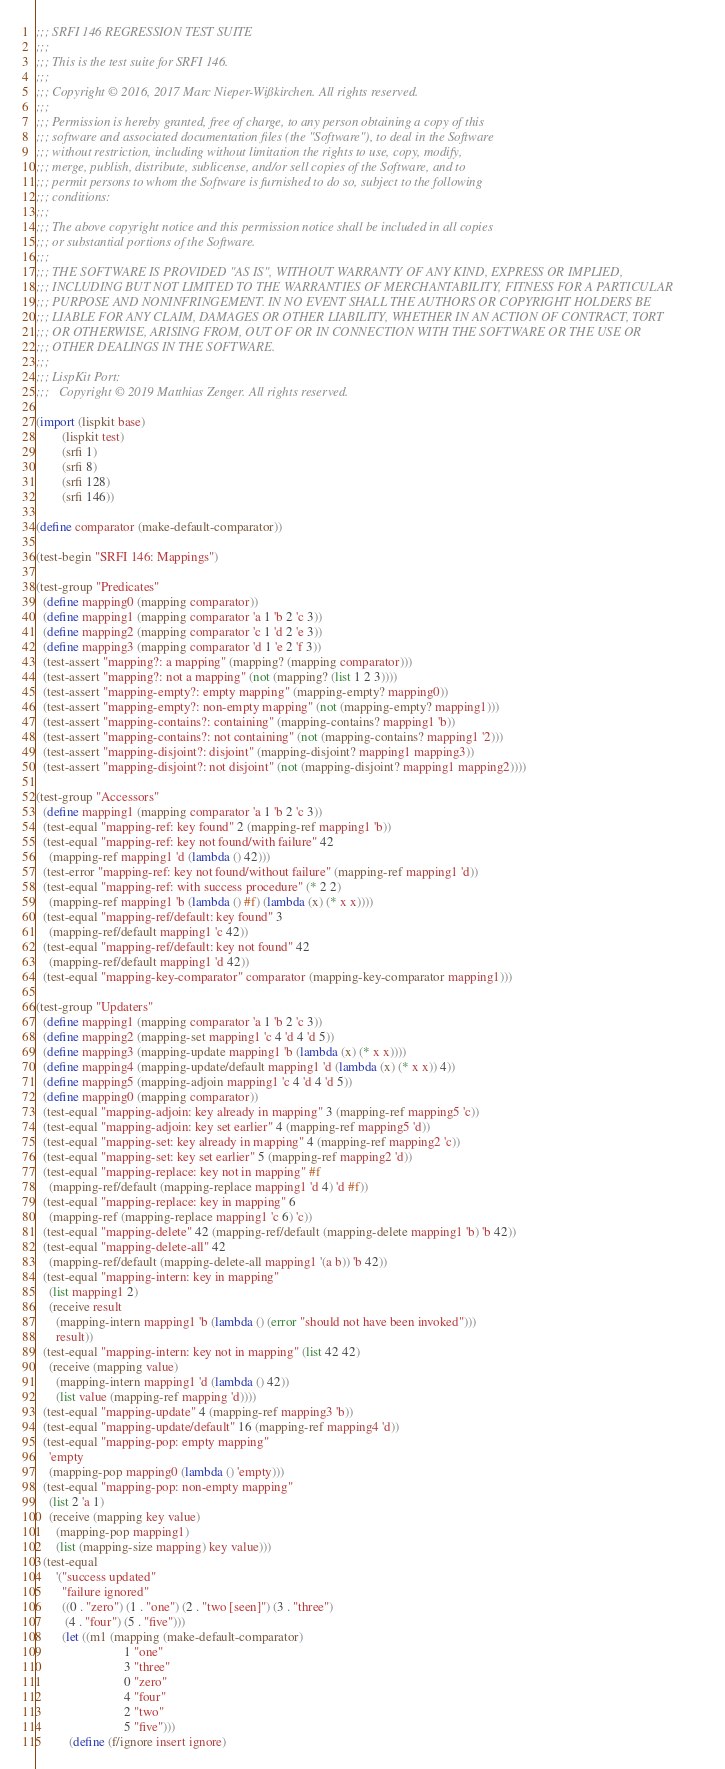Convert code to text. <code><loc_0><loc_0><loc_500><loc_500><_Scheme_>;;; SRFI 146 REGRESSION TEST SUITE
;;;
;;; This is the test suite for SRFI 146.
;;;
;;; Copyright © 2016, 2017 Marc Nieper-Wißkirchen. All rights reserved.
;;;
;;; Permission is hereby granted, free of charge, to any person obtaining a copy of this
;;; software and associated documentation files (the "Software"), to deal in the Software
;;; without restriction, including without limitation the rights to use, copy, modify,
;;; merge, publish, distribute, sublicense, and/or sell copies of the Software, and to
;;; permit persons to whom the Software is furnished to do so, subject to the following
;;; conditions:
;;;
;;; The above copyright notice and this permission notice shall be included in all copies
;;; or substantial portions of the Software.
;;;
;;; THE SOFTWARE IS PROVIDED "AS IS", WITHOUT WARRANTY OF ANY KIND, EXPRESS OR IMPLIED,
;;; INCLUDING BUT NOT LIMITED TO THE WARRANTIES OF MERCHANTABILITY, FITNESS FOR A PARTICULAR
;;; PURPOSE AND NONINFRINGEMENT. IN NO EVENT SHALL THE AUTHORS OR COPYRIGHT HOLDERS BE
;;; LIABLE FOR ANY CLAIM, DAMAGES OR OTHER LIABILITY, WHETHER IN AN ACTION OF CONTRACT, TORT
;;; OR OTHERWISE, ARISING FROM, OUT OF OR IN CONNECTION WITH THE SOFTWARE OR THE USE OR
;;; OTHER DEALINGS IN THE SOFTWARE.
;;;
;;; LispKit Port:
;;;   Copyright © 2019 Matthias Zenger. All rights reserved.

(import (lispkit base)
        (lispkit test)
        (srfi 1)
        (srfi 8)
        (srfi 128)
        (srfi 146))

(define comparator (make-default-comparator))

(test-begin "SRFI 146: Mappings")

(test-group "Predicates"
  (define mapping0 (mapping comparator))
  (define mapping1 (mapping comparator 'a 1 'b 2 'c 3))
  (define mapping2 (mapping comparator 'c 1 'd 2 'e 3))
  (define mapping3 (mapping comparator 'd 1 'e 2 'f 3))
  (test-assert "mapping?: a mapping" (mapping? (mapping comparator)))
  (test-assert "mapping?: not a mapping" (not (mapping? (list 1 2 3))))
  (test-assert "mapping-empty?: empty mapping" (mapping-empty? mapping0))
  (test-assert "mapping-empty?: non-empty mapping" (not (mapping-empty? mapping1)))
  (test-assert "mapping-contains?: containing" (mapping-contains? mapping1 'b))
  (test-assert "mapping-contains?: not containing" (not (mapping-contains? mapping1 '2)))
  (test-assert "mapping-disjoint?: disjoint" (mapping-disjoint? mapping1 mapping3))
  (test-assert "mapping-disjoint?: not disjoint" (not (mapping-disjoint? mapping1 mapping2))))

(test-group "Accessors"
  (define mapping1 (mapping comparator 'a 1 'b 2 'c 3))
  (test-equal "mapping-ref: key found" 2 (mapping-ref mapping1 'b))
  (test-equal "mapping-ref: key not found/with failure" 42
    (mapping-ref mapping1 'd (lambda () 42)))
  (test-error "mapping-ref: key not found/without failure" (mapping-ref mapping1 'd))
  (test-equal "mapping-ref: with success procedure" (* 2 2)
    (mapping-ref mapping1 'b (lambda () #f) (lambda (x) (* x x))))
  (test-equal "mapping-ref/default: key found" 3
    (mapping-ref/default mapping1 'c 42))
  (test-equal "mapping-ref/default: key not found" 42
    (mapping-ref/default mapping1 'd 42))
  (test-equal "mapping-key-comparator" comparator (mapping-key-comparator mapping1)))

(test-group "Updaters"
  (define mapping1 (mapping comparator 'a 1 'b 2 'c 3))
  (define mapping2 (mapping-set mapping1 'c 4 'd 4 'd 5))
  (define mapping3 (mapping-update mapping1 'b (lambda (x) (* x x))))
  (define mapping4 (mapping-update/default mapping1 'd (lambda (x) (* x x)) 4))
  (define mapping5 (mapping-adjoin mapping1 'c 4 'd 4 'd 5))
  (define mapping0 (mapping comparator))
  (test-equal "mapping-adjoin: key already in mapping" 3 (mapping-ref mapping5 'c))
  (test-equal "mapping-adjoin: key set earlier" 4 (mapping-ref mapping5 'd))
  (test-equal "mapping-set: key already in mapping" 4 (mapping-ref mapping2 'c))
  (test-equal "mapping-set: key set earlier" 5 (mapping-ref mapping2 'd))
  (test-equal "mapping-replace: key not in mapping" #f
    (mapping-ref/default (mapping-replace mapping1 'd 4) 'd #f))
  (test-equal "mapping-replace: key in mapping" 6
    (mapping-ref (mapping-replace mapping1 'c 6) 'c))
  (test-equal "mapping-delete" 42 (mapping-ref/default (mapping-delete mapping1 'b) 'b 42))
  (test-equal "mapping-delete-all" 42
    (mapping-ref/default (mapping-delete-all mapping1 '(a b)) 'b 42))
  (test-equal "mapping-intern: key in mapping"
    (list mapping1 2)
    (receive result
      (mapping-intern mapping1 'b (lambda () (error "should not have been invoked")))
      result))
  (test-equal "mapping-intern: key not in mapping" (list 42 42)
    (receive (mapping value)
      (mapping-intern mapping1 'd (lambda () 42))
      (list value (mapping-ref mapping 'd))))
  (test-equal "mapping-update" 4 (mapping-ref mapping3 'b))
  (test-equal "mapping-update/default" 16 (mapping-ref mapping4 'd))
  (test-equal "mapping-pop: empty mapping"
    'empty
    (mapping-pop mapping0 (lambda () 'empty)))
  (test-equal "mapping-pop: non-empty mapping"
    (list 2 'a 1)
    (receive (mapping key value)
      (mapping-pop mapping1)
      (list (mapping-size mapping) key value)))
  (test-equal
      '("success updated"
        "failure ignored"
        ((0 . "zero") (1 . "one") (2 . "two [seen]") (3 . "three")
         (4 . "four") (5 . "five")))
        (let ((m1 (mapping (make-default-comparator)
                           1 "one"
                           3 "three"
                           0 "zero"
                           4 "four"
                           2 "two"
                           5 "five")))
          (define (f/ignore insert ignore)</code> 